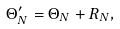Convert formula to latex. <formula><loc_0><loc_0><loc_500><loc_500>\Theta _ { N } ^ { \prime } = \Theta _ { N } + R _ { N } ,</formula> 